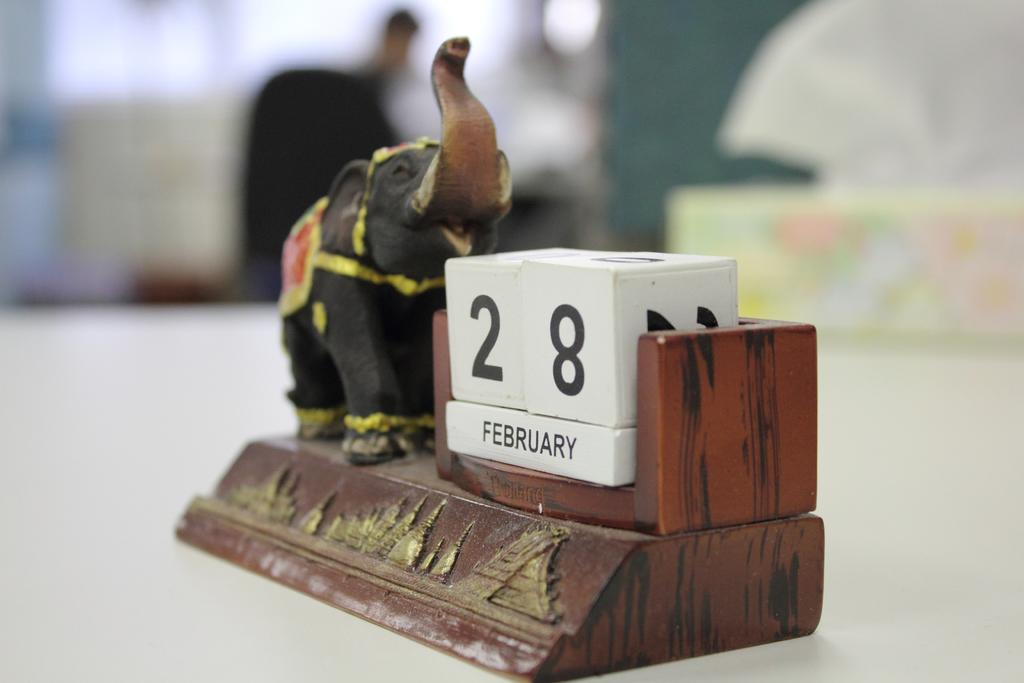<image>
Summarize the visual content of the image. an old calender is marked to the date february 28th 